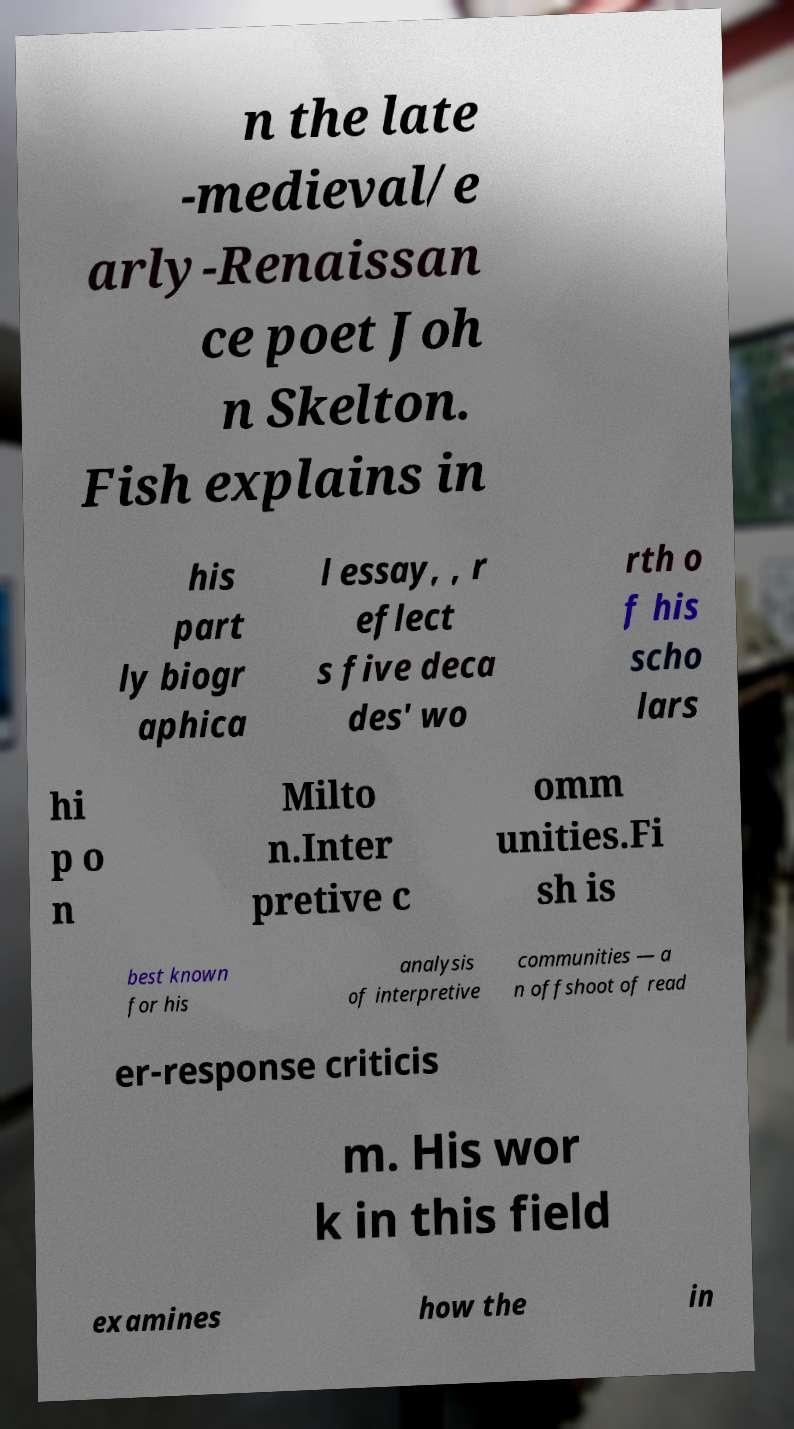Can you accurately transcribe the text from the provided image for me? n the late -medieval/e arly-Renaissan ce poet Joh n Skelton. Fish explains in his part ly biogr aphica l essay, , r eflect s five deca des' wo rth o f his scho lars hi p o n Milto n.Inter pretive c omm unities.Fi sh is best known for his analysis of interpretive communities — a n offshoot of read er-response criticis m. His wor k in this field examines how the in 